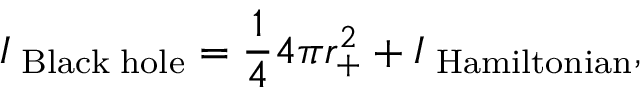Convert formula to latex. <formula><loc_0><loc_0><loc_500><loc_500>I _ { B l a c k h o l e } = \frac { 1 } { 4 } 4 \pi r _ { + } ^ { 2 } + I _ { H a m i l t o n i a n } ,</formula> 